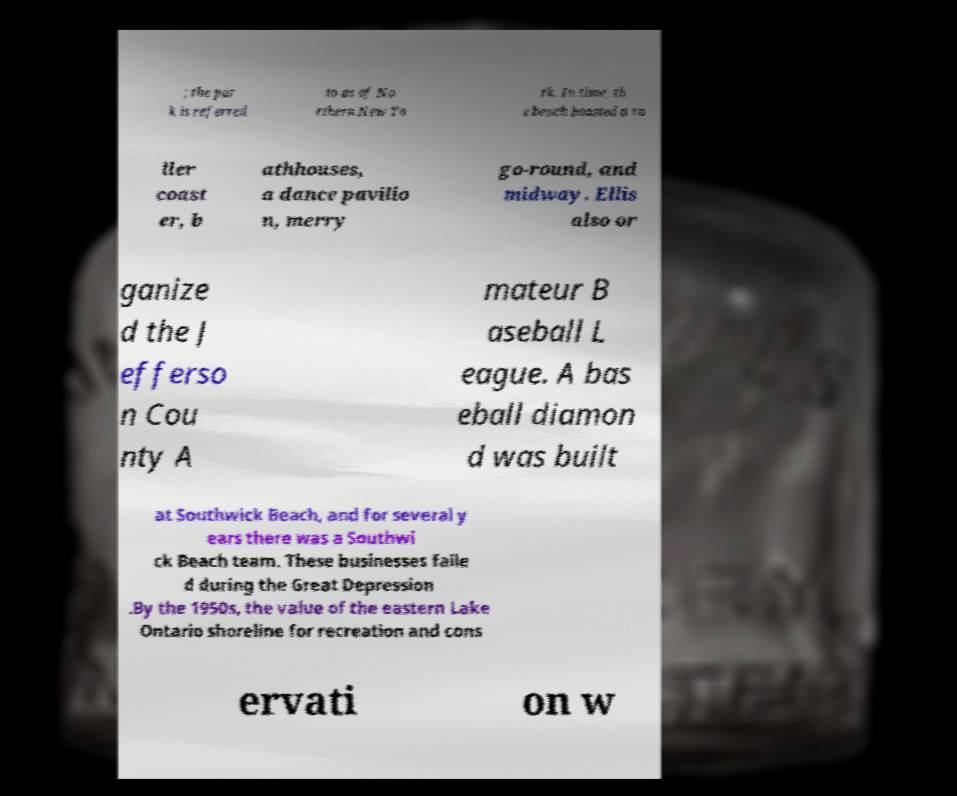There's text embedded in this image that I need extracted. Can you transcribe it verbatim? ; the par k is referred to as of No rthern New Yo rk. In time, th e beach boasted a ro ller coast er, b athhouses, a dance pavilio n, merry go-round, and midway. Ellis also or ganize d the J efferso n Cou nty A mateur B aseball L eague. A bas eball diamon d was built at Southwick Beach, and for several y ears there was a Southwi ck Beach team. These businesses faile d during the Great Depression .By the 1950s, the value of the eastern Lake Ontario shoreline for recreation and cons ervati on w 